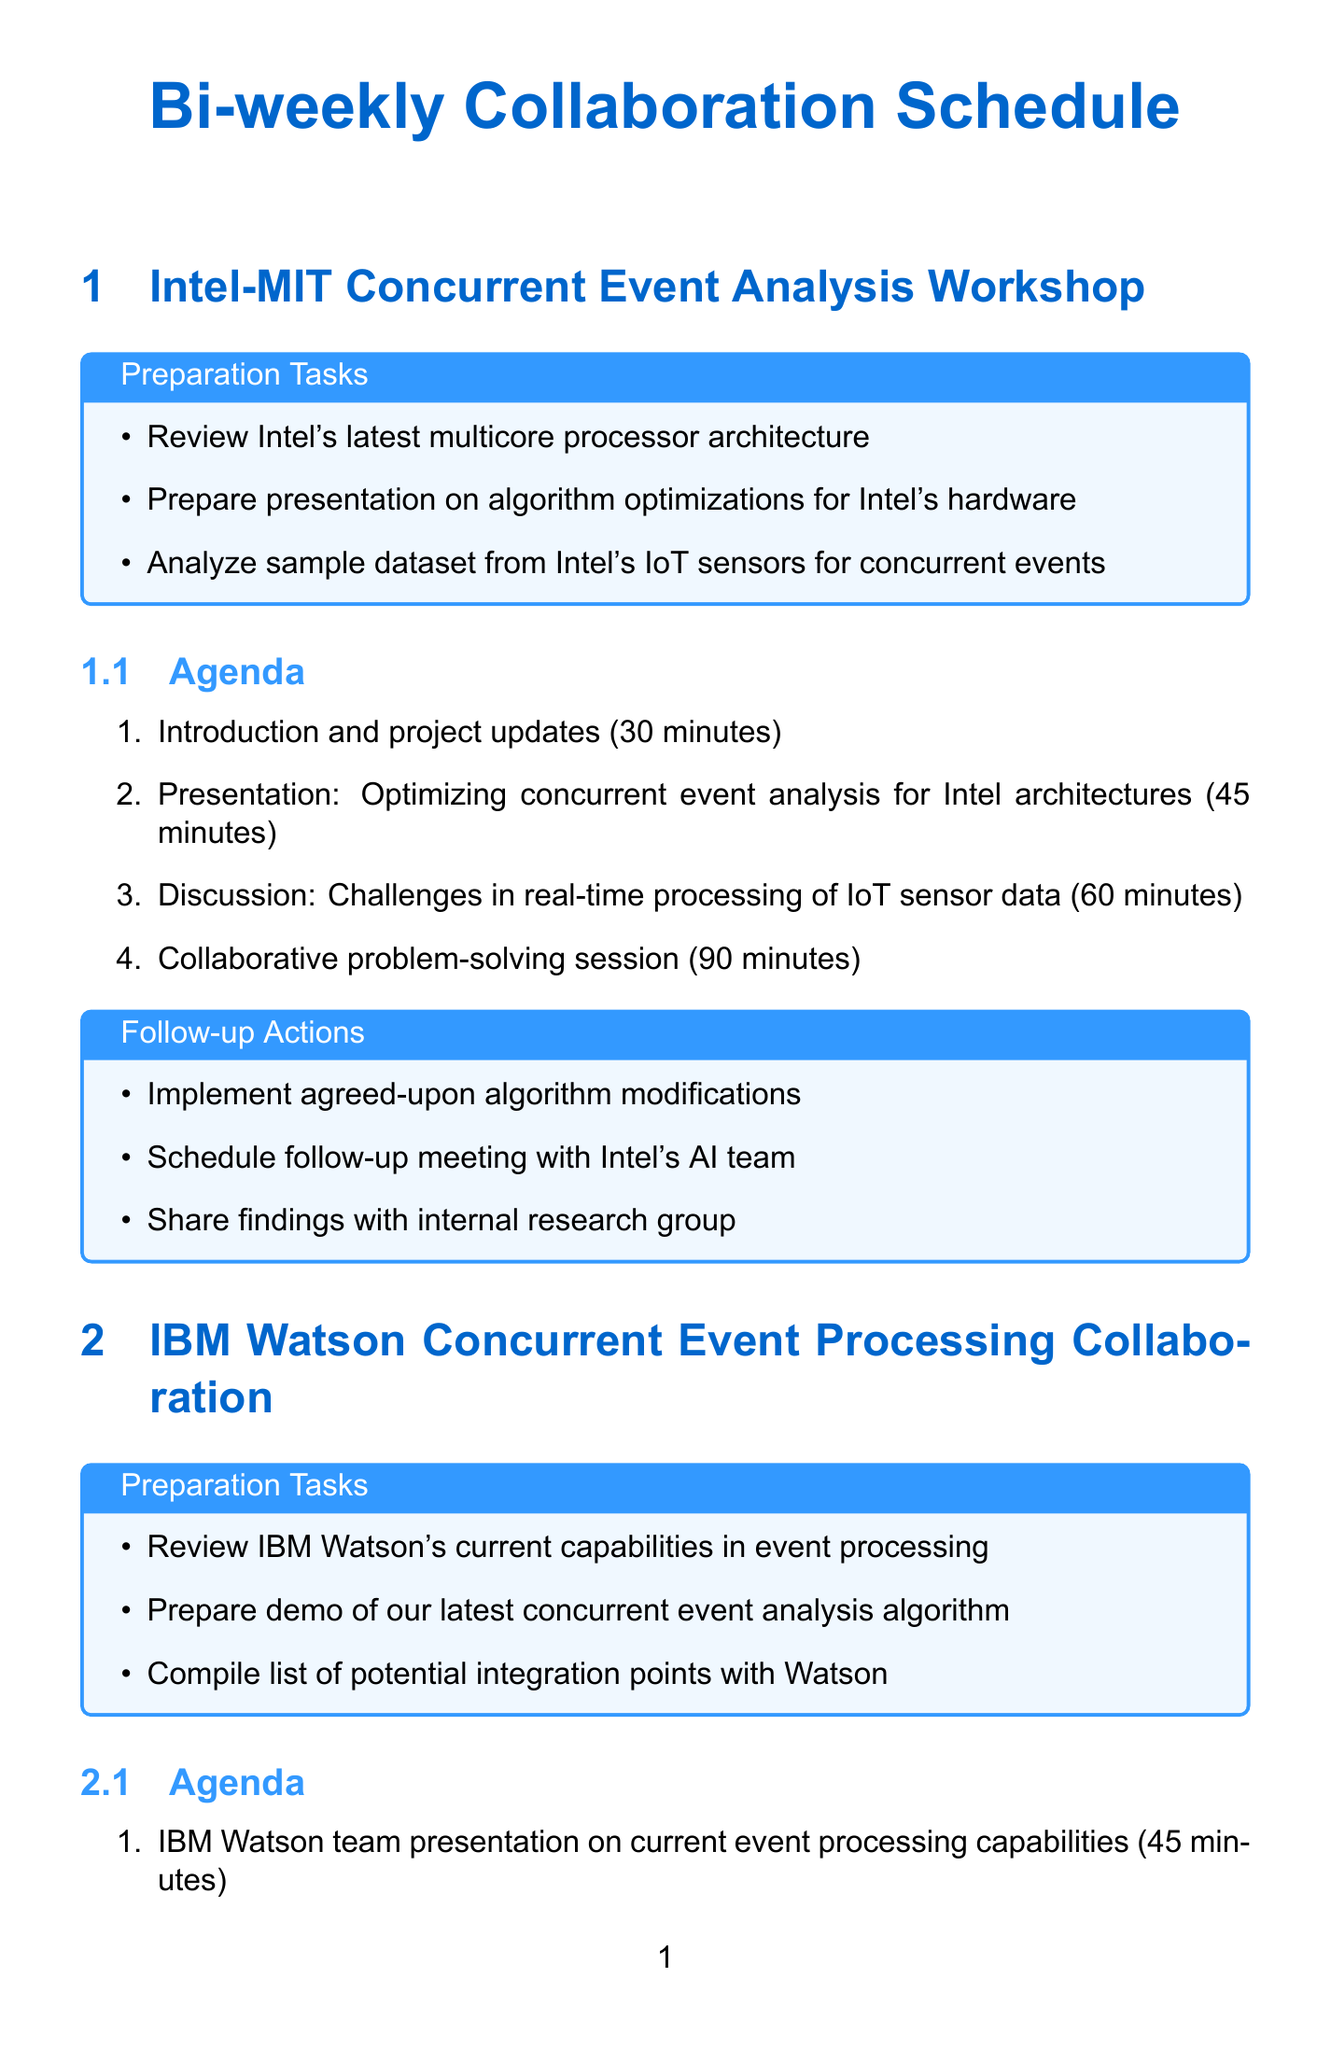what is the name of the first collaboration session? The name of the first collaboration session is presented in the document under the title of the section.
Answer: Intel-MIT Concurrent Event Analysis Workshop how many minutes are allocated for the collaborative problem-solving session? The document outlines the duration of each agenda item, including the collaborative problem-solving session.
Answer: 90 minutes what is the follow-up action item for the NVIDIA session? Each collaboration session lists follow-up actions to be taken after the meeting; one of them specifies an action associated with NVIDIA.
Answer: Incorporate NVIDIA engineer suggestions into our algorithm what are the preparation tasks for the AWS session? The document provides a bulleted list of tasks to be completed before the AWS session, giving an overview of what needs to be prepared.
Answer: Analyze AWS Lambda and Kinesis capabilities for our use case, prepare demo of our algorithm running on AWS infrastructure, compile list of scaling challenges for discussion how long is the interactive session for Siemens? The agenda item for the interactive session is included in the document, showing the duration clearly for that section.
Answer: 60 minutes what type of event is the third session? The document names all sessions and their respective focuses; by reading the title of the third section, the session type can be determined.
Answer: Workshop what is a key focus of the session with IBM Watson? The agenda outlines the focus of each session; reading through the items helps identify the main areas of discussion.
Answer: Integrating our algorithm with Watson how many items are listed as follow-up actions for the Amazon Web Services session? The document lists several follow-up actions specific to the Amazon Web Services session, which can be counted to find the total number.
Answer: 3 action items 